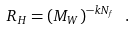Convert formula to latex. <formula><loc_0><loc_0><loc_500><loc_500>R _ { H } = ( M _ { W } ) ^ { - k N _ { f } } \ .</formula> 